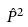<formula> <loc_0><loc_0><loc_500><loc_500>\hat { P } ^ { 2 }</formula> 